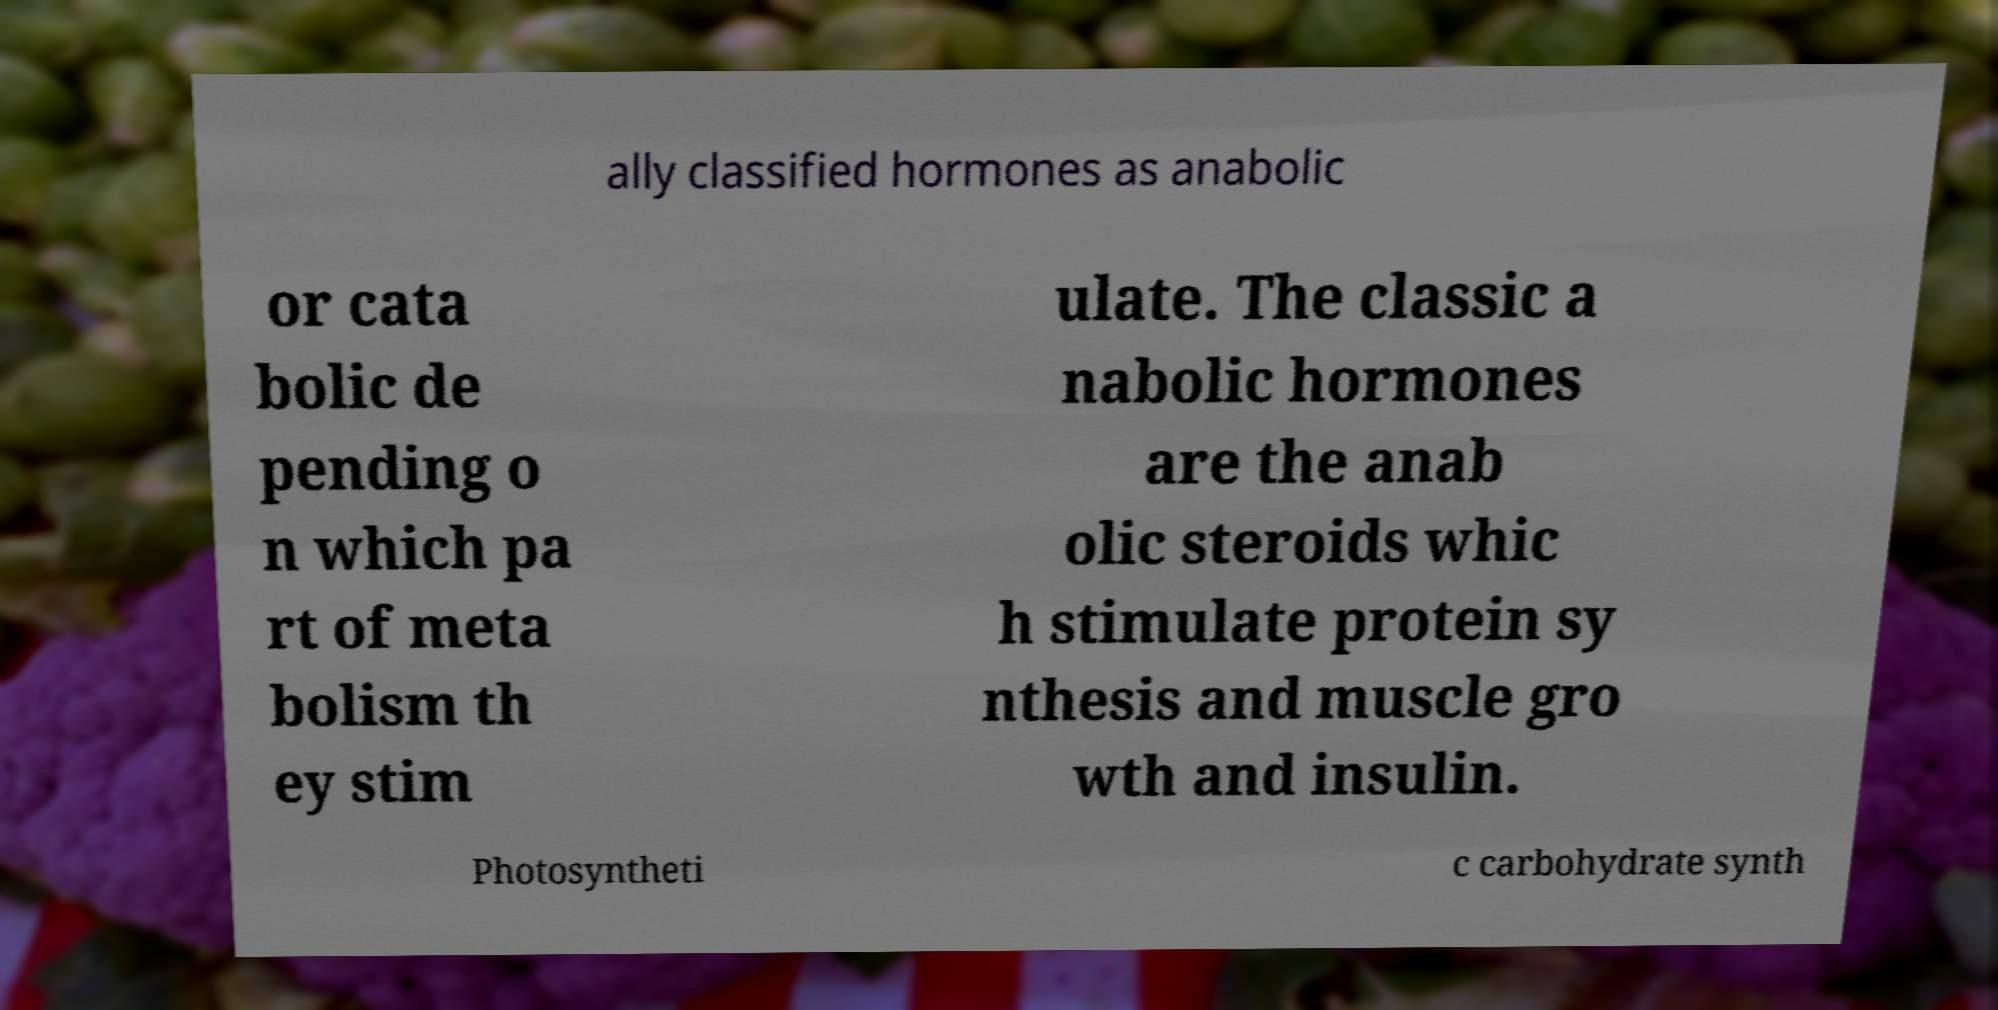Please read and relay the text visible in this image. What does it say? ally classified hormones as anabolic or cata bolic de pending o n which pa rt of meta bolism th ey stim ulate. The classic a nabolic hormones are the anab olic steroids whic h stimulate protein sy nthesis and muscle gro wth and insulin. Photosyntheti c carbohydrate synth 